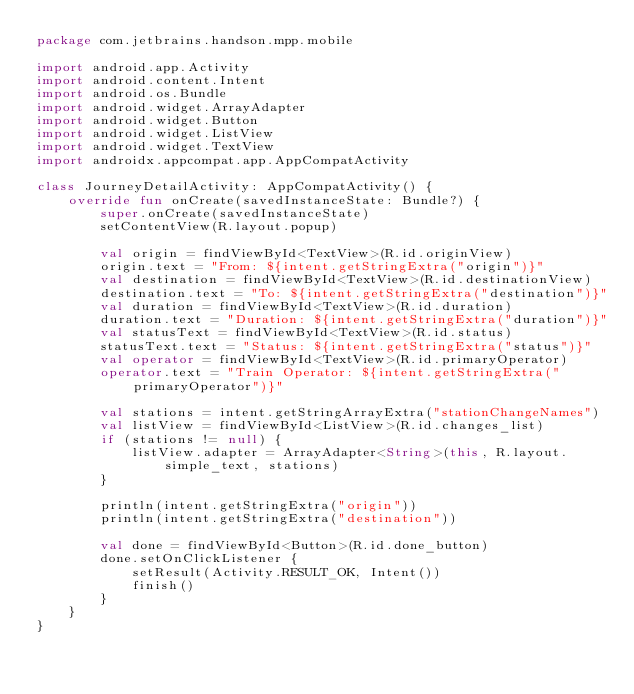Convert code to text. <code><loc_0><loc_0><loc_500><loc_500><_Kotlin_>package com.jetbrains.handson.mpp.mobile

import android.app.Activity
import android.content.Intent
import android.os.Bundle
import android.widget.ArrayAdapter
import android.widget.Button
import android.widget.ListView
import android.widget.TextView
import androidx.appcompat.app.AppCompatActivity

class JourneyDetailActivity: AppCompatActivity() {
    override fun onCreate(savedInstanceState: Bundle?) {
        super.onCreate(savedInstanceState)
        setContentView(R.layout.popup)

        val origin = findViewById<TextView>(R.id.originView)
        origin.text = "From: ${intent.getStringExtra("origin")}"
        val destination = findViewById<TextView>(R.id.destinationView)
        destination.text = "To: ${intent.getStringExtra("destination")}"
        val duration = findViewById<TextView>(R.id.duration)
        duration.text = "Duration: ${intent.getStringExtra("duration")}"
        val statusText = findViewById<TextView>(R.id.status)
        statusText.text = "Status: ${intent.getStringExtra("status")}"
        val operator = findViewById<TextView>(R.id.primaryOperator)
        operator.text = "Train Operator: ${intent.getStringExtra("primaryOperator")}"

        val stations = intent.getStringArrayExtra("stationChangeNames")
        val listView = findViewById<ListView>(R.id.changes_list)
        if (stations != null) {
            listView.adapter = ArrayAdapter<String>(this, R.layout.simple_text, stations)
        }

        println(intent.getStringExtra("origin"))
        println(intent.getStringExtra("destination"))

        val done = findViewById<Button>(R.id.done_button)
        done.setOnClickListener {
            setResult(Activity.RESULT_OK, Intent())
            finish()
        }
    }
}</code> 